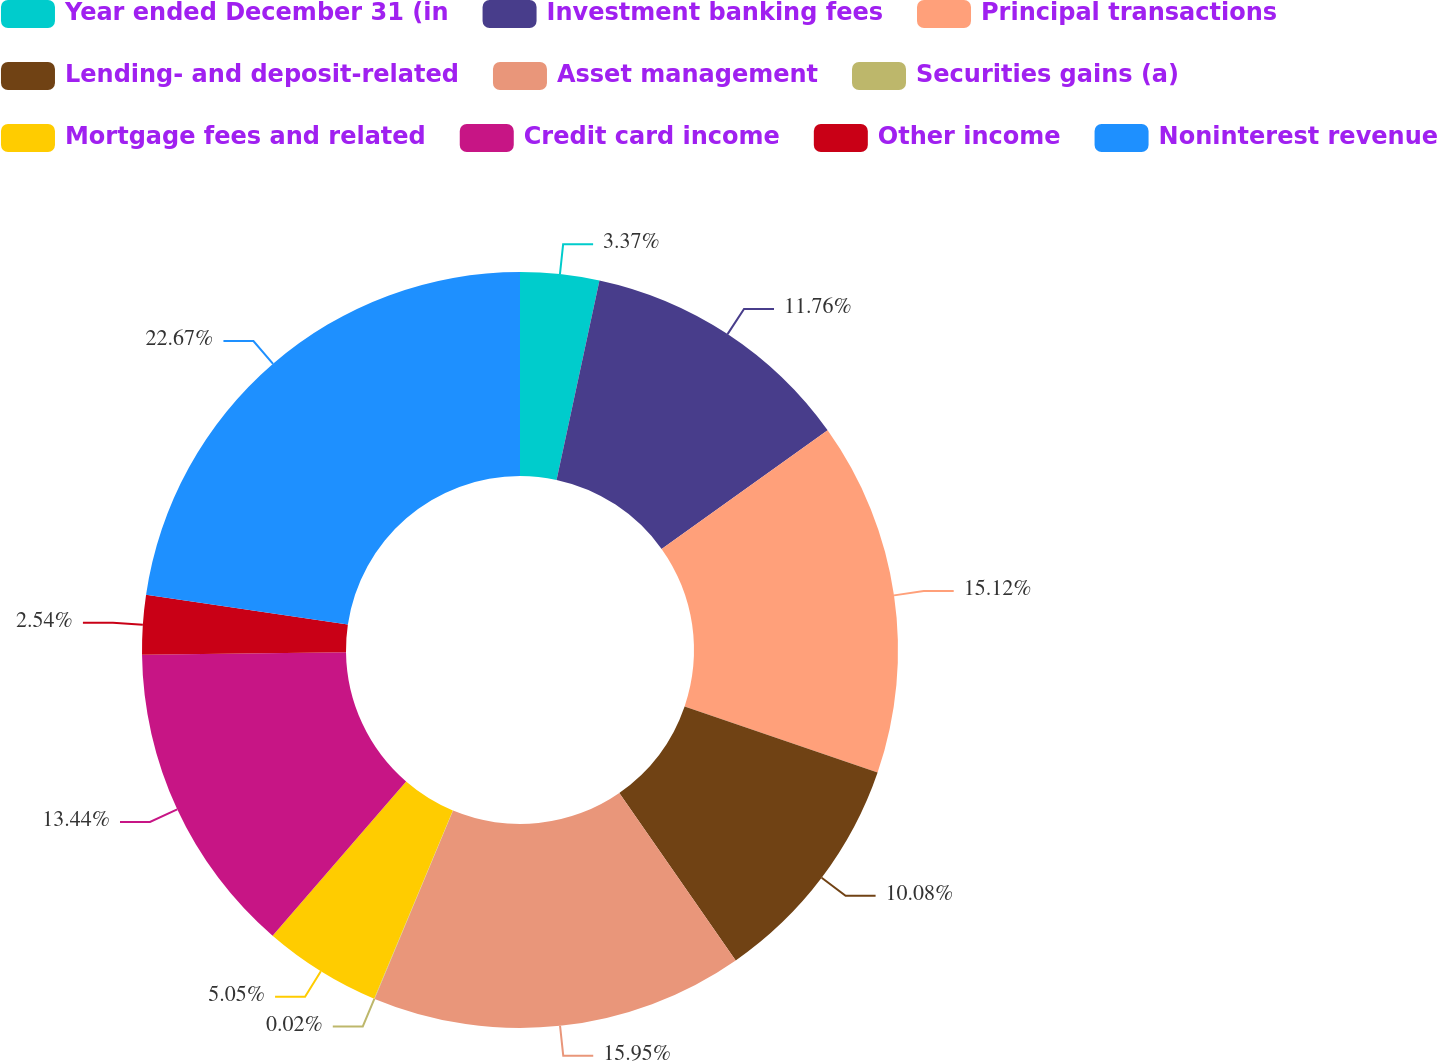Convert chart. <chart><loc_0><loc_0><loc_500><loc_500><pie_chart><fcel>Year ended December 31 (in<fcel>Investment banking fees<fcel>Principal transactions<fcel>Lending- and deposit-related<fcel>Asset management<fcel>Securities gains (a)<fcel>Mortgage fees and related<fcel>Credit card income<fcel>Other income<fcel>Noninterest revenue<nl><fcel>3.37%<fcel>11.76%<fcel>15.12%<fcel>10.08%<fcel>15.95%<fcel>0.02%<fcel>5.05%<fcel>13.44%<fcel>2.54%<fcel>22.66%<nl></chart> 